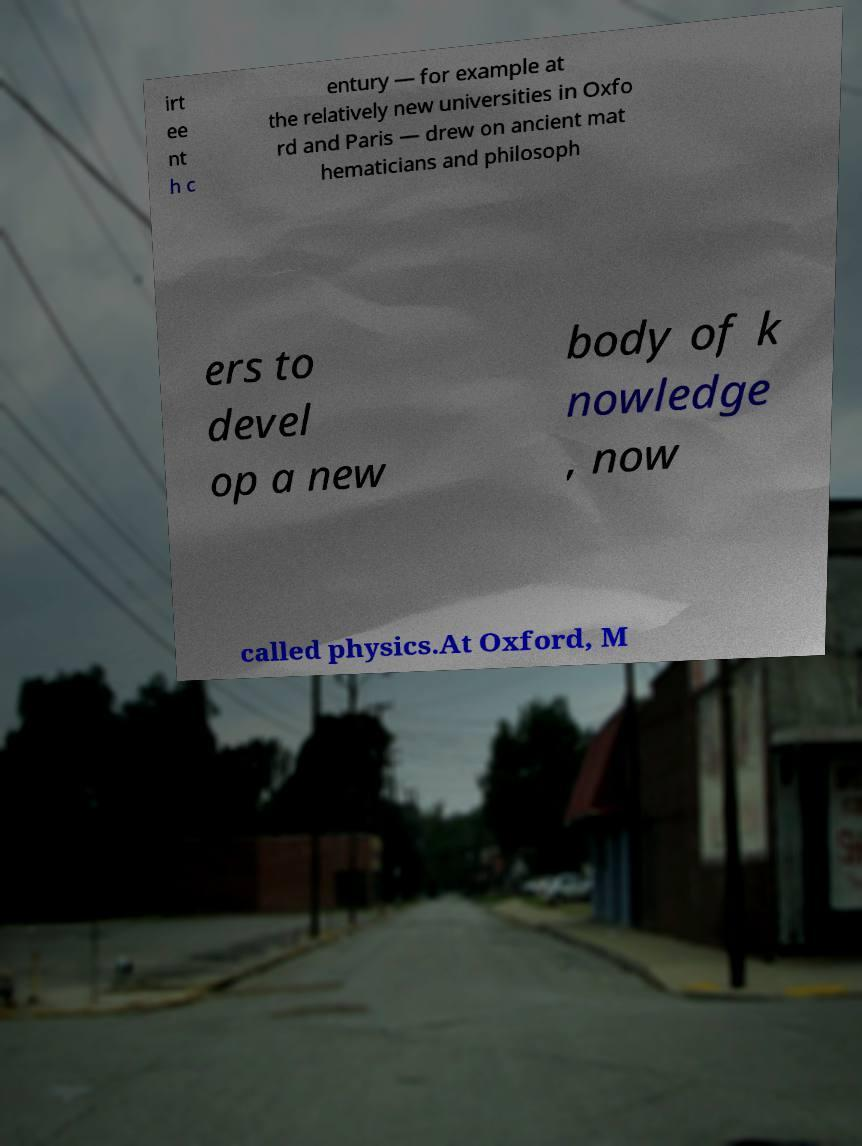There's text embedded in this image that I need extracted. Can you transcribe it verbatim? irt ee nt h c entury — for example at the relatively new universities in Oxfo rd and Paris — drew on ancient mat hematicians and philosoph ers to devel op a new body of k nowledge , now called physics.At Oxford, M 